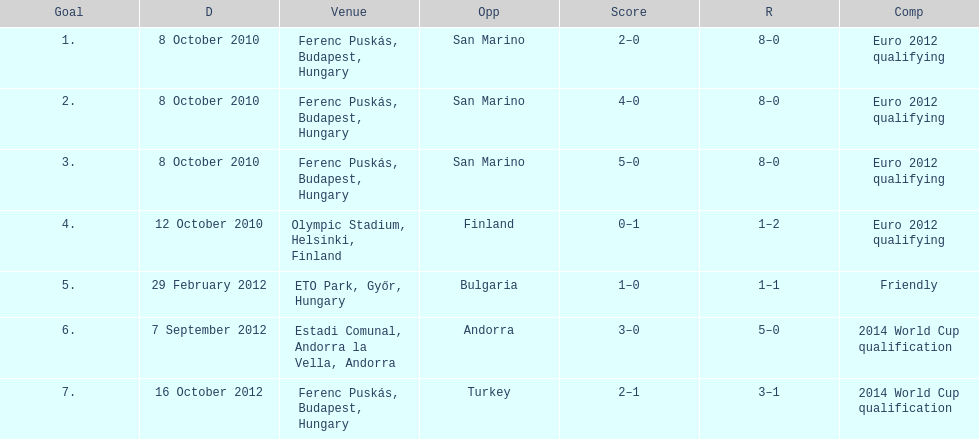How many games did he score but his team lost? 1. 